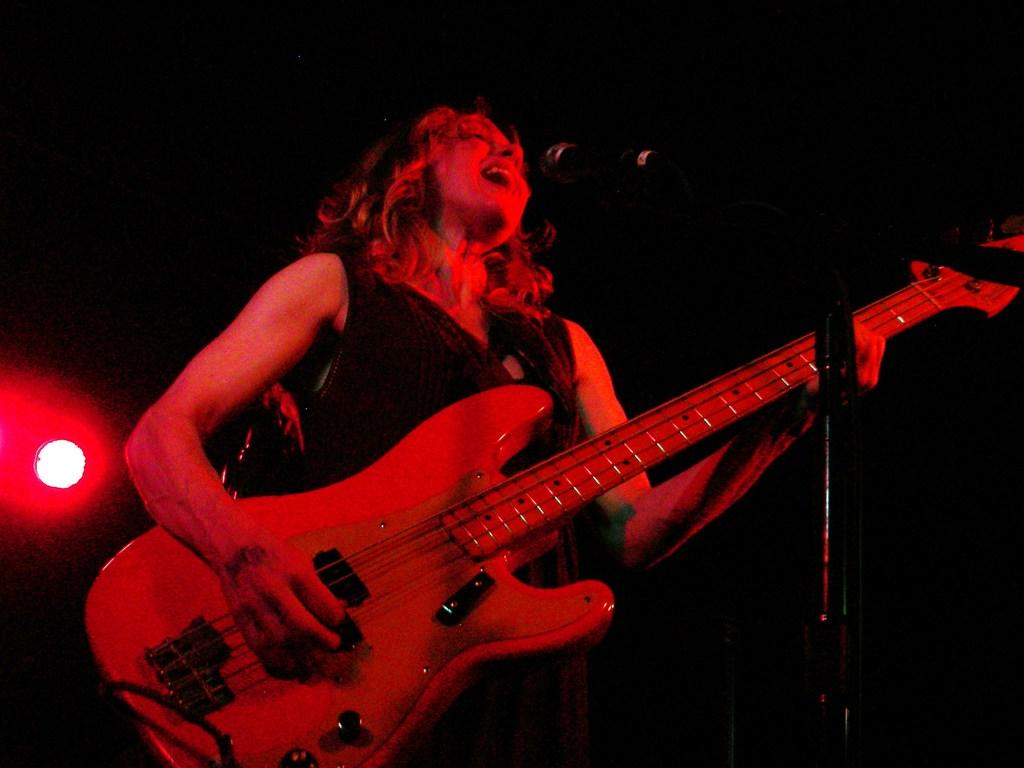Who is the main subject in the image? There is a woman in the image. What is the woman doing in the image? The woman is playing and singing in the image. What object is present at the front of the image? There is a microphone at the front of the image. What can be seen at the back of the image? There is a light at the back of the image. What type of ice can be seen melting on the woman's forehead in the image? There is no ice present on the woman's forehead in the image. What kind of noise can be heard coming from the microphone in the image? The image is a still image, so no sound or noise can be heard from the microphone. 